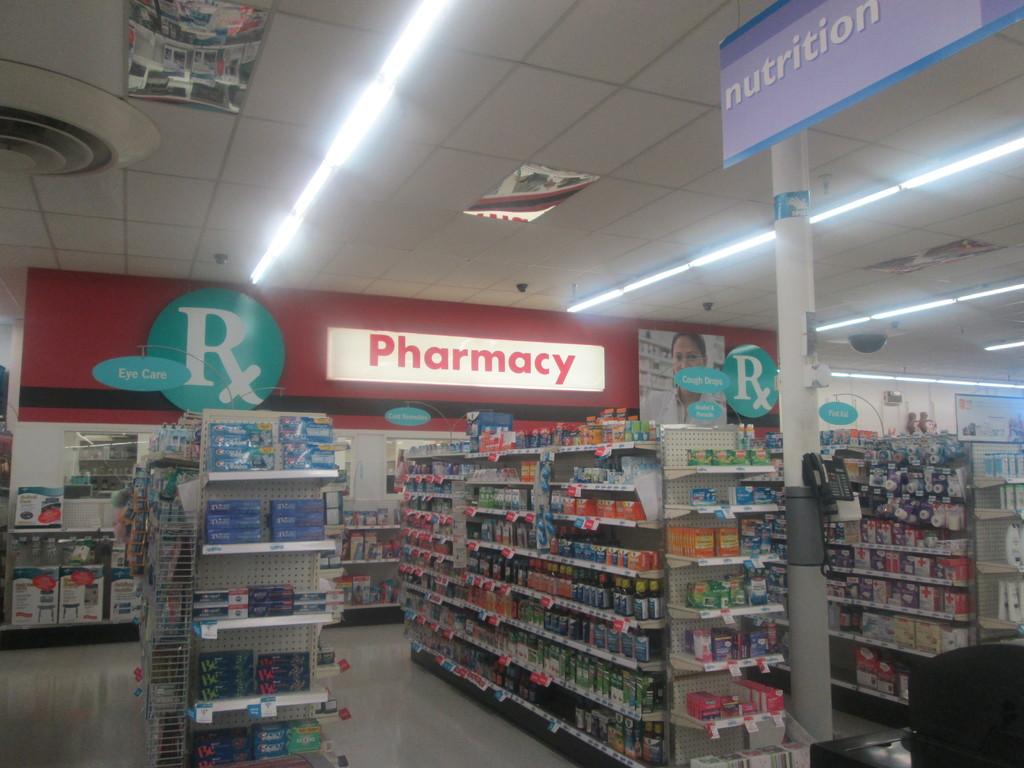What isle is on the right?
Offer a very short reply. Nutrition. Do they fill prescriptions?
Your response must be concise. Yes. 